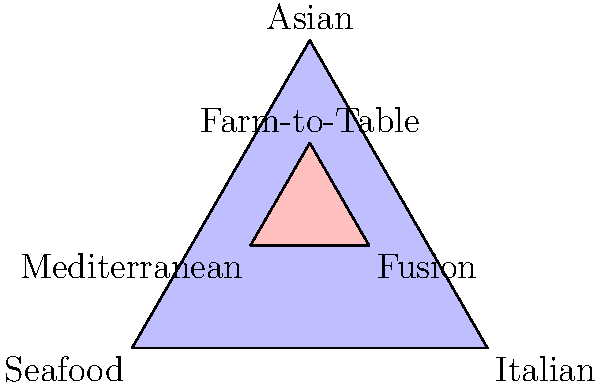In a Venn diagram representing the relationship between artwork themes and cuisine types, three main categories (Seafood, Italian, and Asian) form the outer triangle, while three fusion categories (Mediterranean, Fusion, and Farm-to-Table) form the inner triangle. If a new art exhibition features dishes that combine elements from all six categories, in which area of the diagram would this exhibition's theme be best represented? To answer this question, we need to analyze the Venn diagram and understand the relationships between the different cuisine types:

1. The outer triangle represents three main cuisine categories: Seafood, Italian, and Asian.
2. The inner triangle represents three fusion categories: Mediterranean, Fusion, and Farm-to-Table.
3. The inner triangle is positioned such that each of its vertices is at the center of a side of the outer triangle, indicating a blend of the two adjacent main categories.
4. The exhibition features dishes that combine elements from all six categories.

Given this information:

1. The new exhibition incorporates elements from all three main categories (Seafood, Italian, and Asian).
2. It also includes aspects of all three fusion categories (Mediterranean, Fusion, and Farm-to-Table).
3. To represent a combination of all six categories, we need to find a point that is equally influenced by all areas of the diagram.

The center point of the entire diagram would be the most appropriate location to represent this all-encompassing theme. This point is equidistant from all vertices of both the outer and inner triangles, symbolizing an equal influence from all six cuisine types.

In terms of the diagram, this central point would be located at the intersection of the medians of both the outer and inner triangles. It represents the perfect balance and fusion of all the represented cuisine types and their corresponding artwork themes.
Answer: The center point of the entire diagram 